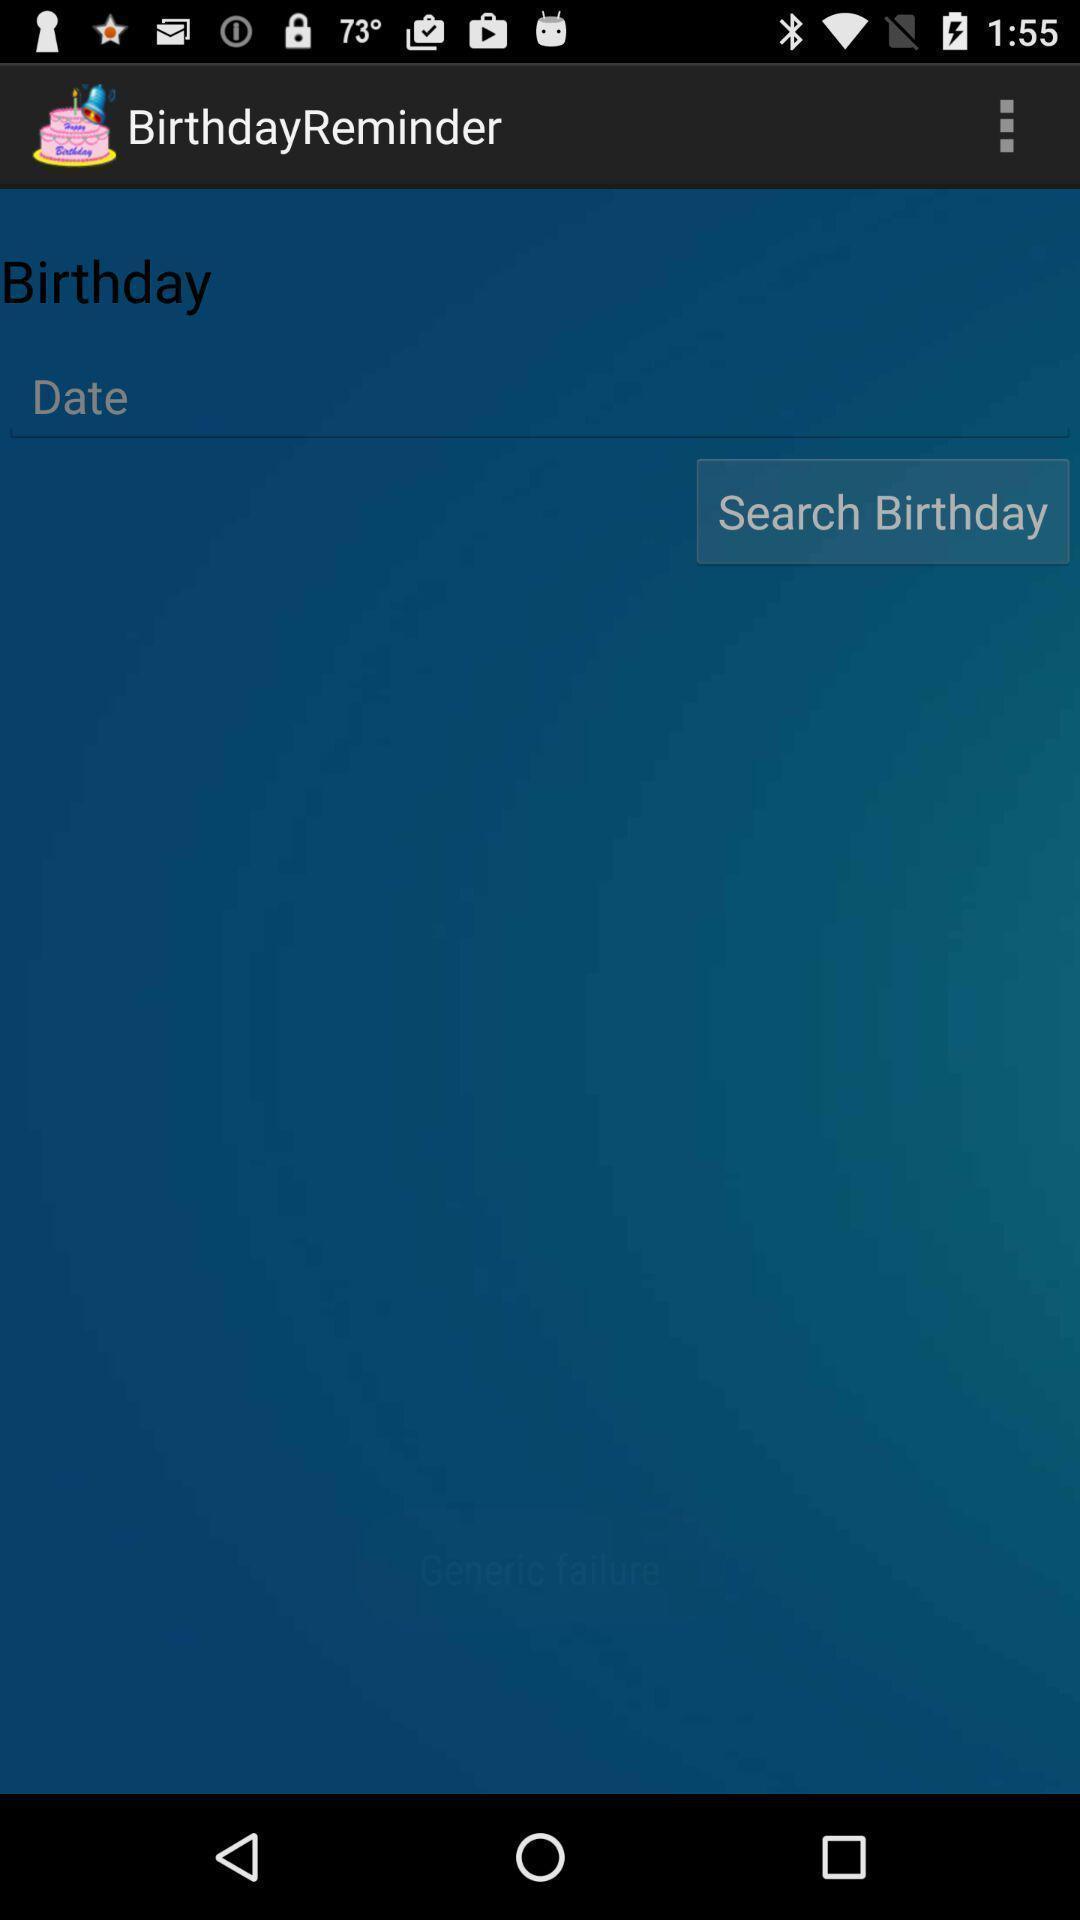Explain the elements present in this screenshot. Screen showing search birthday option. 